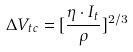<formula> <loc_0><loc_0><loc_500><loc_500>\Delta V _ { t c } = [ \frac { \eta \cdot I _ { t } } { \rho } ] ^ { 2 / 3 }</formula> 